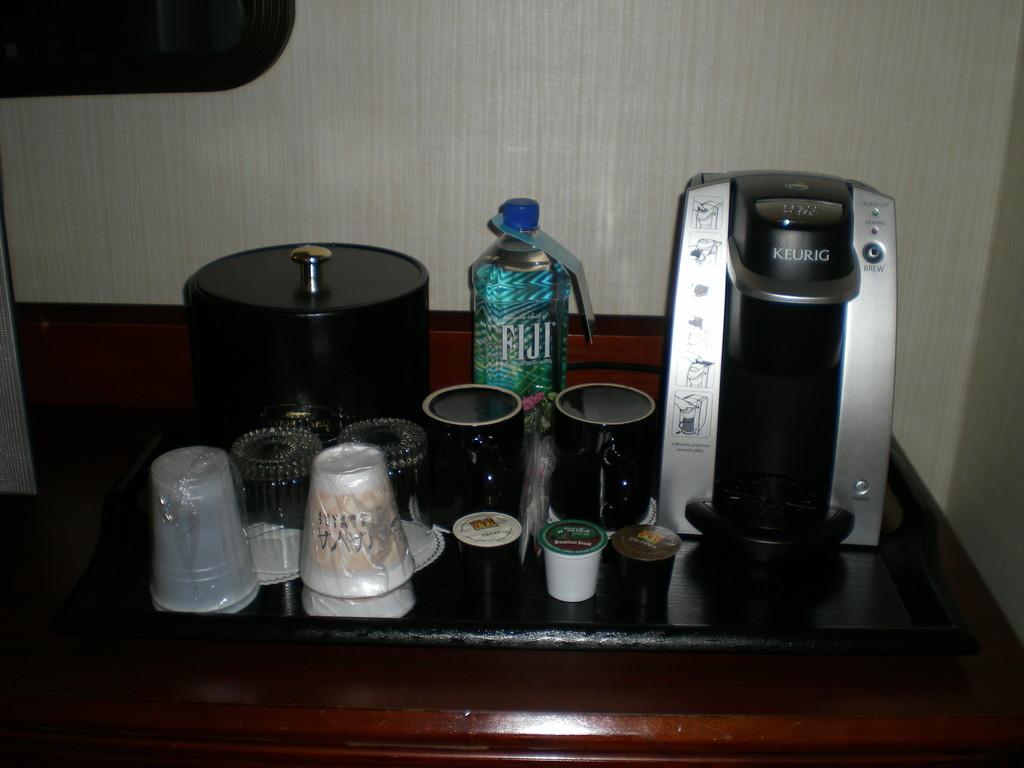What brand of coffee maker is this?
Give a very brief answer. Keurig. 